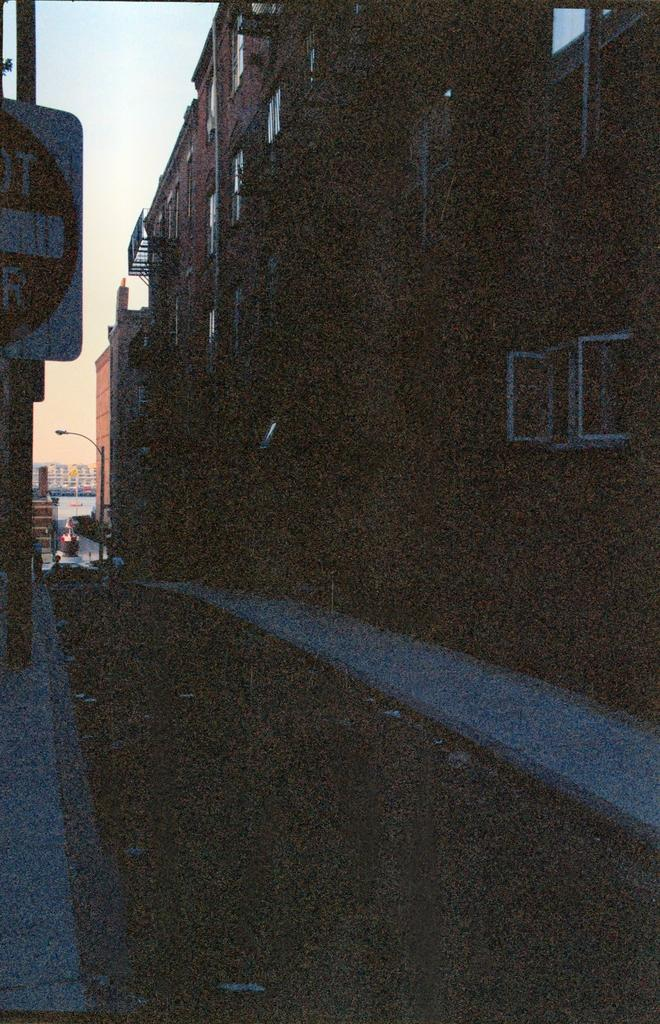What type of structures can be seen in the image? There are buildings in the image. What architectural features are present in the image? There are walls and windows in the image. What is the source of light visible in the image? There is a street light in the image. What can be seen in the background of the image? The sky is visible in the background of the image. What is at the bottom of the image? There is a road and walkways at the bottom of the image. What type of cloth is draped over the buildings in the image? There is no cloth draped over the buildings in the image. What season is depicted in the image? The provided facts do not mention any season, so it cannot be determined from the image. 